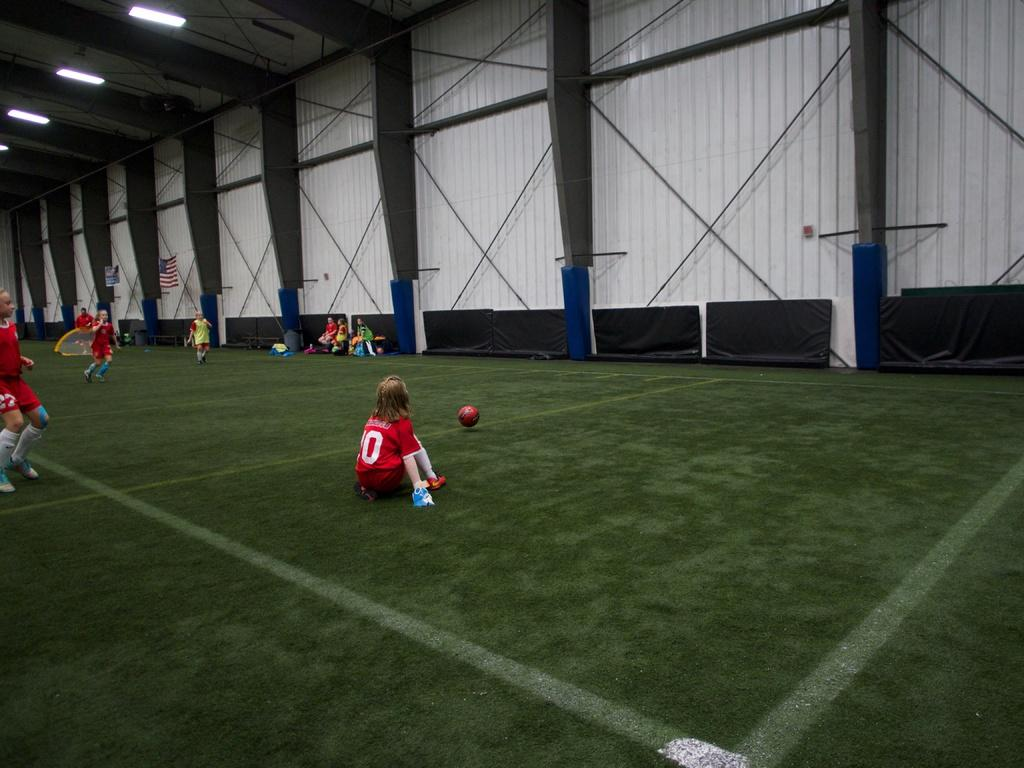What is the main activity taking place in the image? Girls are playing with a ball in the image. What are the girls wearing? The girls are wearing red dresses. What can be seen in the background of the image? There is a wall and flags in the background of the image. What color is the wall in the image? The wall is white in color. What type of paste is being used in the meeting depicted in the image? There is no meeting or paste present in the image; it features girls playing with a ball. What drug is being discussed in the image? There is no drug or discussion about drugs present in the image. 